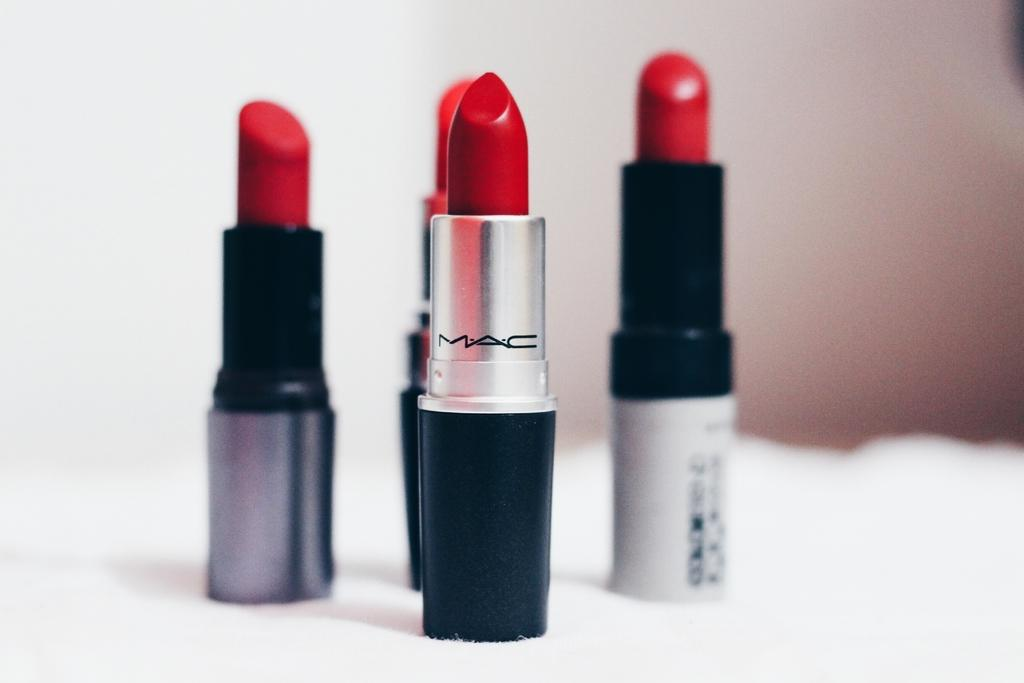What type of cosmetic product is visible in the image? There are lipsticks in the image. Can you describe the background of the image? The background of the image is blurry. How many bikes are parked next to the lipsticks in the image? There are no bikes present in the image; it only features lipsticks and a blurry background. 